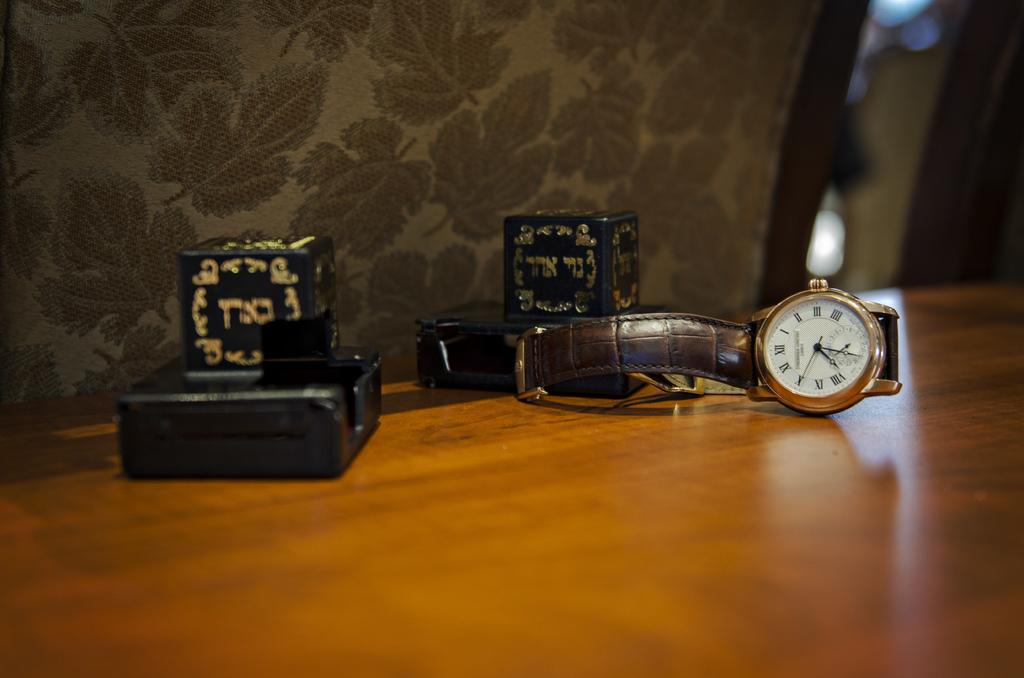<image>
Provide a brief description of the given image. A wristwatch with roman numerals that the time is 12:05. 